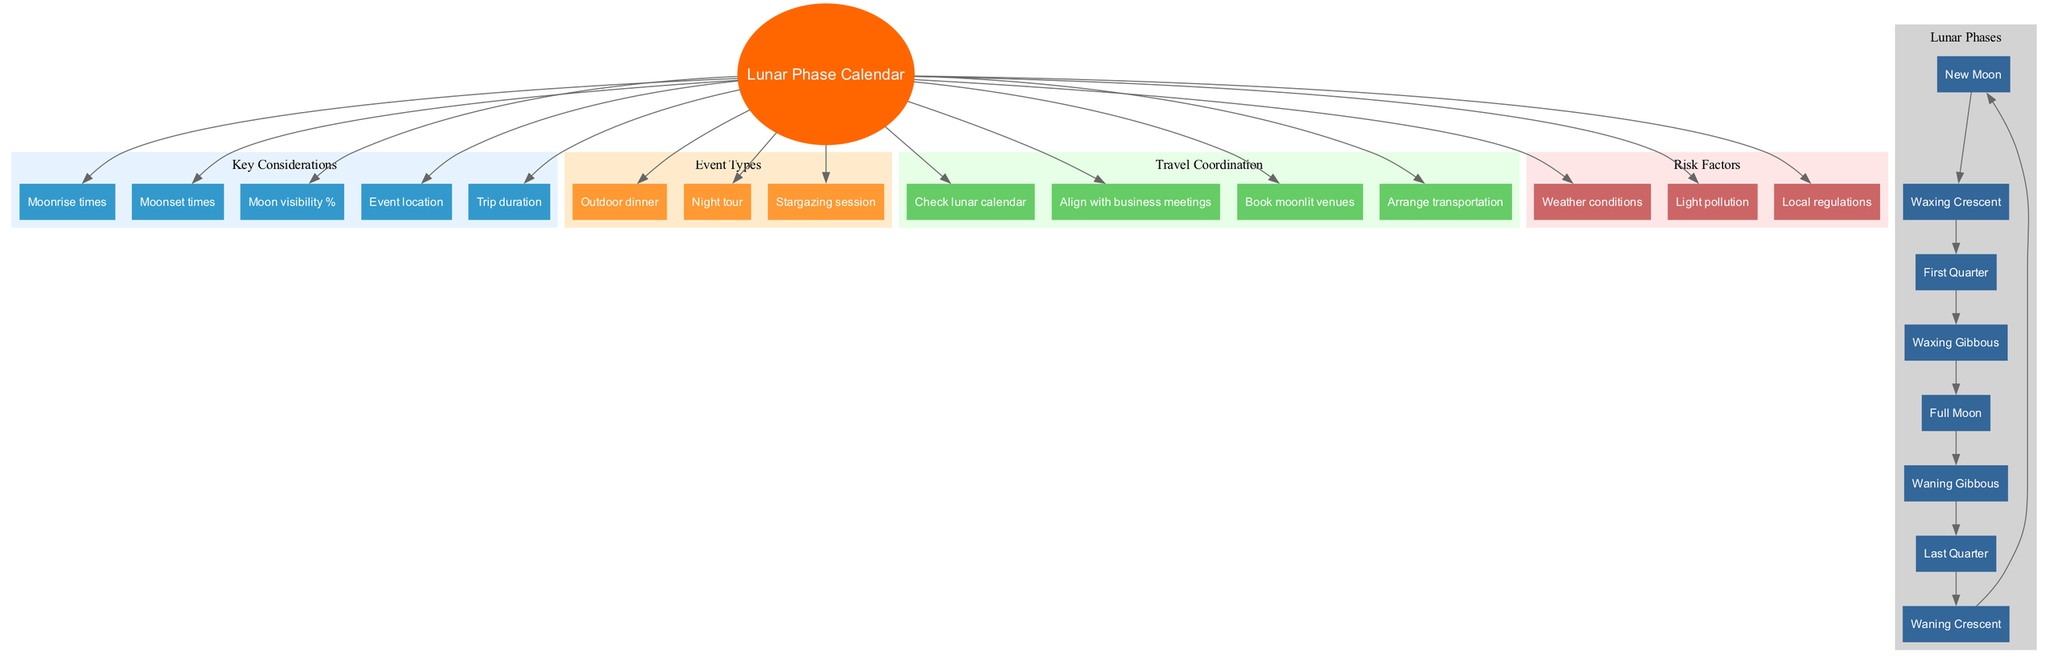What are the eight lunar phases depicted in the diagram? The diagram lists eight lunar phases in a circular flow. These phases include New Moon, Waxing Crescent, First Quarter, Waxing Gibbous, Full Moon, Waning Gibbous, Last Quarter, and Waning Crescent, each connected sequentially.
Answer: New Moon, Waxing Crescent, First Quarter, Waxing Gibbous, Full Moon, Waning Gibbous, Last Quarter, Waning Crescent How many key considerations are included in the diagram? The key considerations are grouped under a specific section in the diagram. There are five distinct nodes listed under this category: Moonrise times, Moonset times, Moon visibility %, Event location, and Trip duration. Counting these gives us a total of five.
Answer: 5 Which event type is positioned closest to the central concept? The diagram shows event types branching out from the central concept. There are three types: Outdoor dinner, Night tour, and Stargazing session. The first event type listed is Outdoor dinner, making it the closest.
Answer: Outdoor dinner What is a key factor that would influence travel coordination? The diagram outlines several travel coordination aspects connected to the central concept. One of these aspects is "Check lunar calendar," which helps ensure scheduling aligns with lunar phases.
Answer: Check lunar calendar Identify one risk factor mentioned in the diagram that could affect moonlit events. The diagram specifies multiple risk factors, one of which is "Weather conditions." This indicates that weather can disrupt events planned for moonlit nights.
Answer: Weather conditions What phase follows the Full Moon in the lunar phases? According to the flow of the lunar phases in the diagram, after Full Moon, the next phase indicated is Waning Gibbous. This follows the sequence outlined in the flow.
Answer: Waning Gibbous How many edges connect the key considerations to the central concept? Each key consideration node is connected to the central concept with one edge each. Since there are five key considerations, there are five edges connecting them to the central concept.
Answer: 5 Which phase is the last in the sequence before returning to New Moon? The lunar phases in the diagram form a loop. The last phase listed before circling back to New Moon is Waning Crescent. This completes the cycle of lunar phases.
Answer: Waning Crescent 